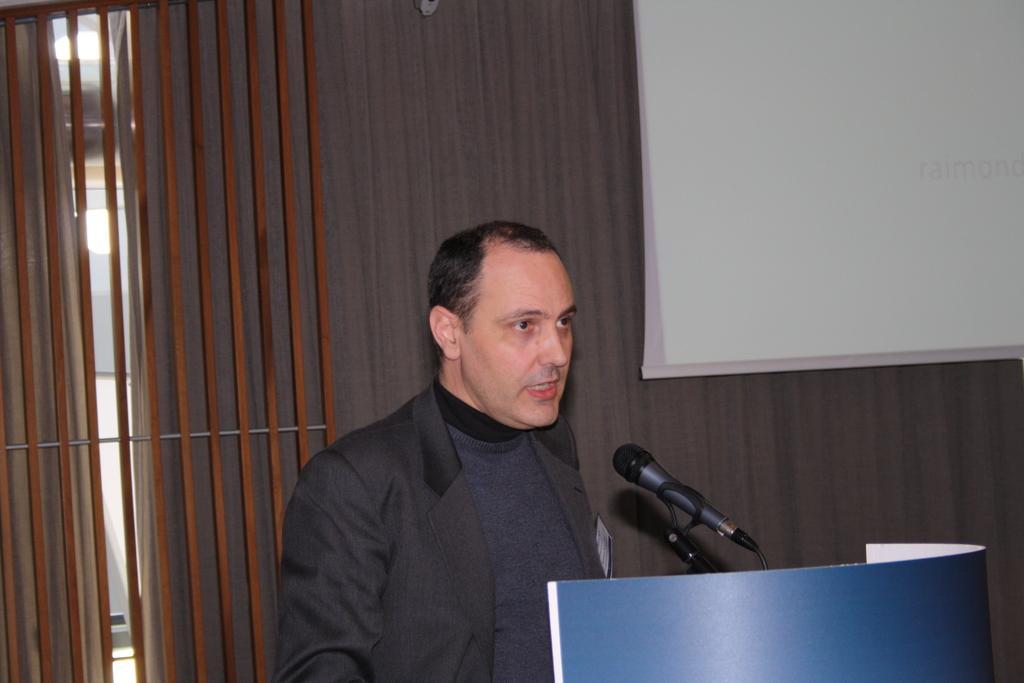Can you describe this image briefly? There is a man talking on the mike and this is a podium. In the background we can see a curtain, lights, and a screen. 